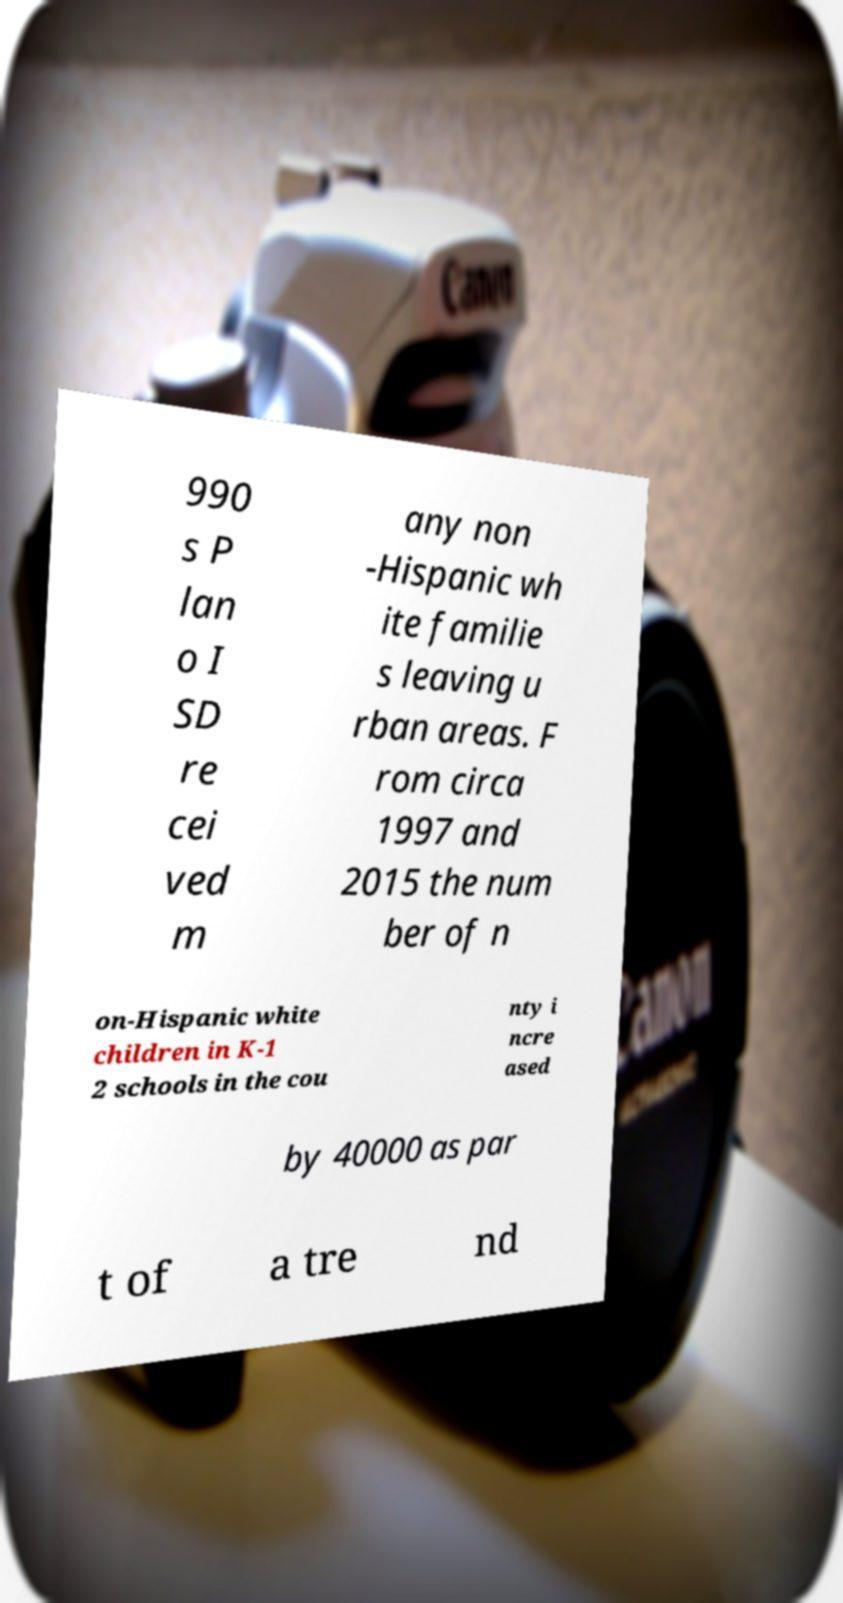Could you extract and type out the text from this image? 990 s P lan o I SD re cei ved m any non -Hispanic wh ite familie s leaving u rban areas. F rom circa 1997 and 2015 the num ber of n on-Hispanic white children in K-1 2 schools in the cou nty i ncre ased by 40000 as par t of a tre nd 